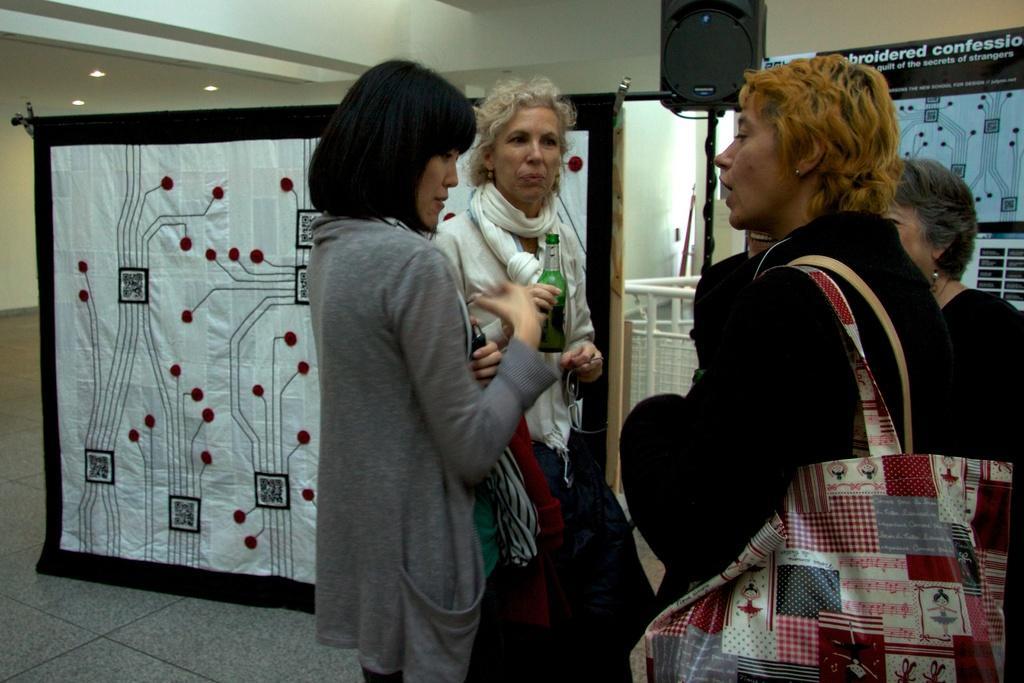In one or two sentences, can you explain what this image depicts? In the image there are group of people standing and wearing their handbags,glasses and holding a bottle. On right side there is a hoarding,speakers. On left side there is a curtain, in background there is a wall which is in white color. 